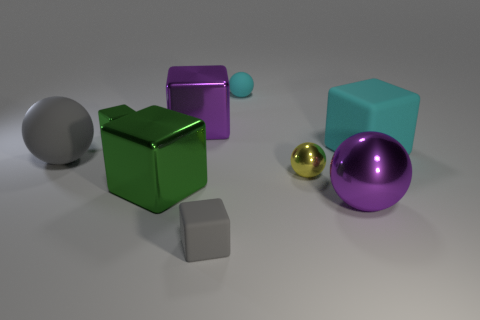Subtract all green blocks. How many were subtracted if there are1green blocks left? 1 Subtract all yellow cylinders. How many green cubes are left? 2 Subtract all cyan balls. How many balls are left? 3 Add 1 purple metal things. How many objects exist? 10 Subtract all green cubes. How many cubes are left? 3 Subtract all balls. How many objects are left? 5 Subtract 1 cubes. How many cubes are left? 4 Subtract 0 brown cubes. How many objects are left? 9 Subtract all blue spheres. Subtract all gray blocks. How many spheres are left? 4 Subtract all large cyan cylinders. Subtract all green metal cubes. How many objects are left? 7 